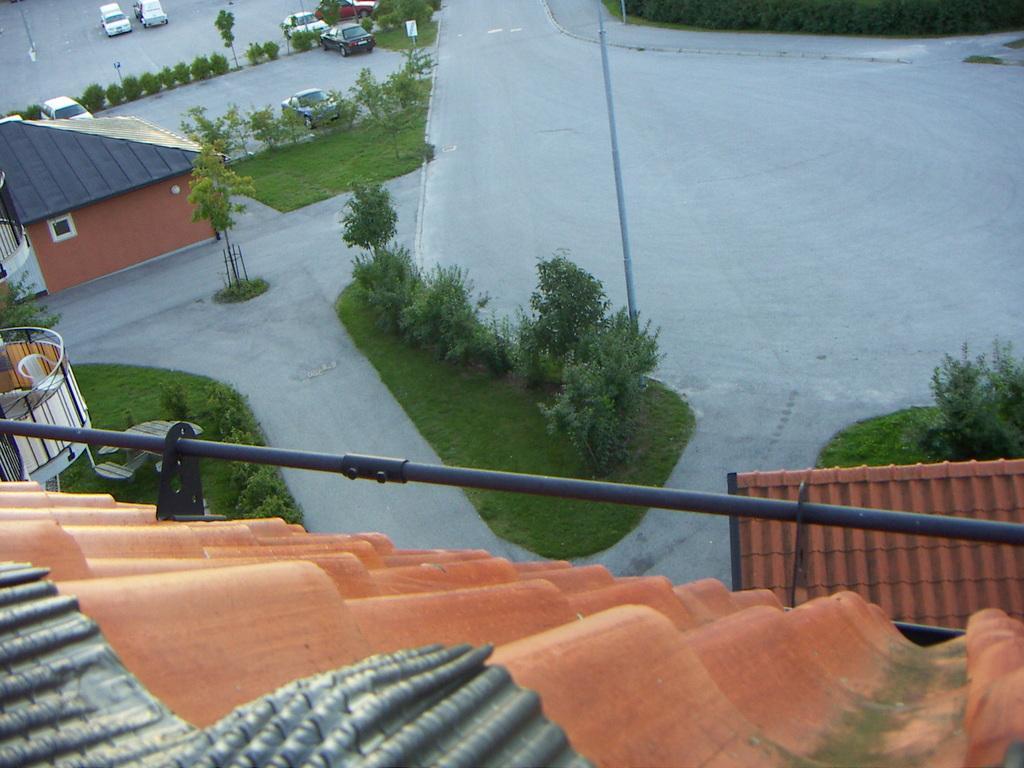Could you give a brief overview of what you see in this image? In this picture I can see the roof of the building and black pipe. In the center I can see the trees, plants and grass. Beside that I can see the roads and pole. On the left I can see some chairs on the roof of the building. Beside that there is a reeling. At the top I can see many cars which are parked near to the plants. 